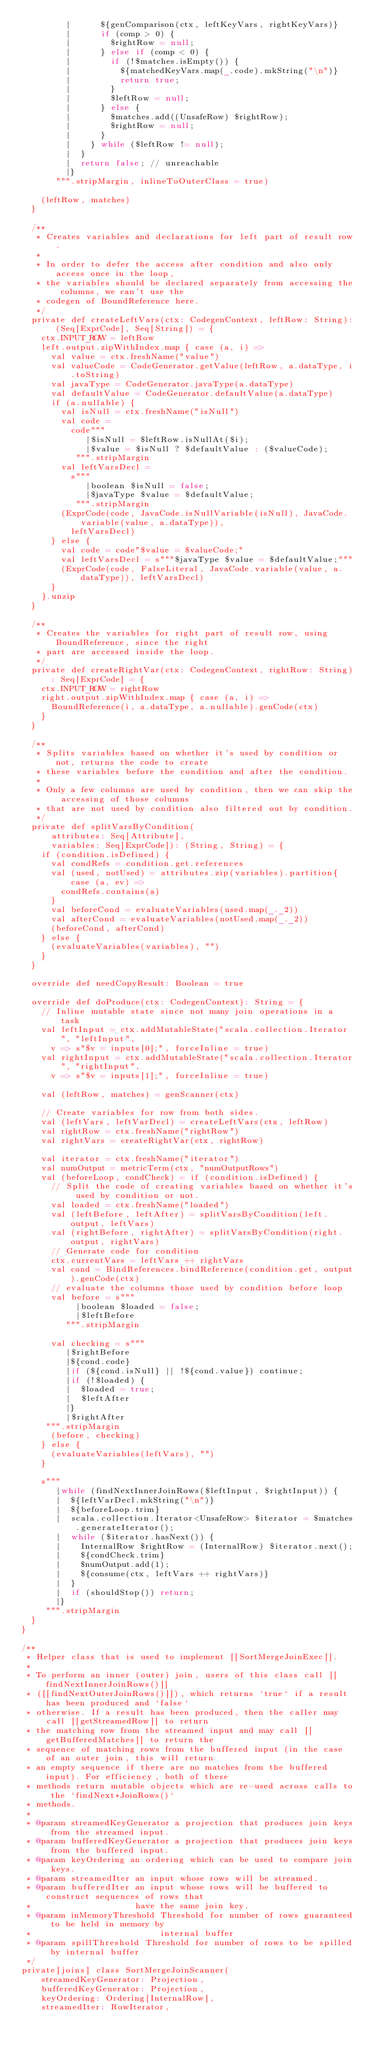<code> <loc_0><loc_0><loc_500><loc_500><_Scala_>         |      ${genComparison(ctx, leftKeyVars, rightKeyVars)}
         |      if (comp > 0) {
         |        $rightRow = null;
         |      } else if (comp < 0) {
         |        if (!$matches.isEmpty()) {
         |          ${matchedKeyVars.map(_.code).mkString("\n")}
         |          return true;
         |        }
         |        $leftRow = null;
         |      } else {
         |        $matches.add((UnsafeRow) $rightRow);
         |        $rightRow = null;
         |      }
         |    } while ($leftRow != null);
         |  }
         |  return false; // unreachable
         |}
       """.stripMargin, inlineToOuterClass = true)

    (leftRow, matches)
  }

  /**
   * Creates variables and declarations for left part of result row.
   *
   * In order to defer the access after condition and also only access once in the loop,
   * the variables should be declared separately from accessing the columns, we can't use the
   * codegen of BoundReference here.
   */
  private def createLeftVars(ctx: CodegenContext, leftRow: String): (Seq[ExprCode], Seq[String]) = {
    ctx.INPUT_ROW = leftRow
    left.output.zipWithIndex.map { case (a, i) =>
      val value = ctx.freshName("value")
      val valueCode = CodeGenerator.getValue(leftRow, a.dataType, i.toString)
      val javaType = CodeGenerator.javaType(a.dataType)
      val defaultValue = CodeGenerator.defaultValue(a.dataType)
      if (a.nullable) {
        val isNull = ctx.freshName("isNull")
        val code =
          code"""
             |$isNull = $leftRow.isNullAt($i);
             |$value = $isNull ? $defaultValue : ($valueCode);
           """.stripMargin
        val leftVarsDecl =
          s"""
             |boolean $isNull = false;
             |$javaType $value = $defaultValue;
           """.stripMargin
        (ExprCode(code, JavaCode.isNullVariable(isNull), JavaCode.variable(value, a.dataType)),
          leftVarsDecl)
      } else {
        val code = code"$value = $valueCode;"
        val leftVarsDecl = s"""$javaType $value = $defaultValue;"""
        (ExprCode(code, FalseLiteral, JavaCode.variable(value, a.dataType)), leftVarsDecl)
      }
    }.unzip
  }

  /**
   * Creates the variables for right part of result row, using BoundReference, since the right
   * part are accessed inside the loop.
   */
  private def createRightVar(ctx: CodegenContext, rightRow: String): Seq[ExprCode] = {
    ctx.INPUT_ROW = rightRow
    right.output.zipWithIndex.map { case (a, i) =>
      BoundReference(i, a.dataType, a.nullable).genCode(ctx)
    }
  }

  /**
   * Splits variables based on whether it's used by condition or not, returns the code to create
   * these variables before the condition and after the condition.
   *
   * Only a few columns are used by condition, then we can skip the accessing of those columns
   * that are not used by condition also filtered out by condition.
   */
  private def splitVarsByCondition(
      attributes: Seq[Attribute],
      variables: Seq[ExprCode]): (String, String) = {
    if (condition.isDefined) {
      val condRefs = condition.get.references
      val (used, notUsed) = attributes.zip(variables).partition{ case (a, ev) =>
        condRefs.contains(a)
      }
      val beforeCond = evaluateVariables(used.map(_._2))
      val afterCond = evaluateVariables(notUsed.map(_._2))
      (beforeCond, afterCond)
    } else {
      (evaluateVariables(variables), "")
    }
  }

  override def needCopyResult: Boolean = true

  override def doProduce(ctx: CodegenContext): String = {
    // Inline mutable state since not many join operations in a task
    val leftInput = ctx.addMutableState("scala.collection.Iterator", "leftInput",
      v => s"$v = inputs[0];", forceInline = true)
    val rightInput = ctx.addMutableState("scala.collection.Iterator", "rightInput",
      v => s"$v = inputs[1];", forceInline = true)

    val (leftRow, matches) = genScanner(ctx)

    // Create variables for row from both sides.
    val (leftVars, leftVarDecl) = createLeftVars(ctx, leftRow)
    val rightRow = ctx.freshName("rightRow")
    val rightVars = createRightVar(ctx, rightRow)

    val iterator = ctx.freshName("iterator")
    val numOutput = metricTerm(ctx, "numOutputRows")
    val (beforeLoop, condCheck) = if (condition.isDefined) {
      // Split the code of creating variables based on whether it's used by condition or not.
      val loaded = ctx.freshName("loaded")
      val (leftBefore, leftAfter) = splitVarsByCondition(left.output, leftVars)
      val (rightBefore, rightAfter) = splitVarsByCondition(right.output, rightVars)
      // Generate code for condition
      ctx.currentVars = leftVars ++ rightVars
      val cond = BindReferences.bindReference(condition.get, output).genCode(ctx)
      // evaluate the columns those used by condition before loop
      val before = s"""
           |boolean $loaded = false;
           |$leftBefore
         """.stripMargin

      val checking = s"""
         |$rightBefore
         |${cond.code}
         |if (${cond.isNull} || !${cond.value}) continue;
         |if (!$loaded) {
         |  $loaded = true;
         |  $leftAfter
         |}
         |$rightAfter
     """.stripMargin
      (before, checking)
    } else {
      (evaluateVariables(leftVars), "")
    }

    s"""
       |while (findNextInnerJoinRows($leftInput, $rightInput)) {
       |  ${leftVarDecl.mkString("\n")}
       |  ${beforeLoop.trim}
       |  scala.collection.Iterator<UnsafeRow> $iterator = $matches.generateIterator();
       |  while ($iterator.hasNext()) {
       |    InternalRow $rightRow = (InternalRow) $iterator.next();
       |    ${condCheck.trim}
       |    $numOutput.add(1);
       |    ${consume(ctx, leftVars ++ rightVars)}
       |  }
       |  if (shouldStop()) return;
       |}
     """.stripMargin
  }
}

/**
 * Helper class that is used to implement [[SortMergeJoinExec]].
 *
 * To perform an inner (outer) join, users of this class call [[findNextInnerJoinRows()]]
 * ([[findNextOuterJoinRows()]]), which returns `true` if a result has been produced and `false`
 * otherwise. If a result has been produced, then the caller may call [[getStreamedRow]] to return
 * the matching row from the streamed input and may call [[getBufferedMatches]] to return the
 * sequence of matching rows from the buffered input (in the case of an outer join, this will return
 * an empty sequence if there are no matches from the buffered input). For efficiency, both of these
 * methods return mutable objects which are re-used across calls to the `findNext*JoinRows()`
 * methods.
 *
 * @param streamedKeyGenerator a projection that produces join keys from the streamed input.
 * @param bufferedKeyGenerator a projection that produces join keys from the buffered input.
 * @param keyOrdering an ordering which can be used to compare join keys.
 * @param streamedIter an input whose rows will be streamed.
 * @param bufferedIter an input whose rows will be buffered to construct sequences of rows that
 *                     have the same join key.
 * @param inMemoryThreshold Threshold for number of rows guaranteed to be held in memory by
 *                          internal buffer
 * @param spillThreshold Threshold for number of rows to be spilled by internal buffer
 */
private[joins] class SortMergeJoinScanner(
    streamedKeyGenerator: Projection,
    bufferedKeyGenerator: Projection,
    keyOrdering: Ordering[InternalRow],
    streamedIter: RowIterator,</code> 